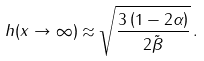Convert formula to latex. <formula><loc_0><loc_0><loc_500><loc_500>h ( x \rightarrow \infty ) \approx \sqrt { \frac { 3 \left ( 1 - 2 \alpha \right ) } { 2 \tilde { \beta } } } \, .</formula> 